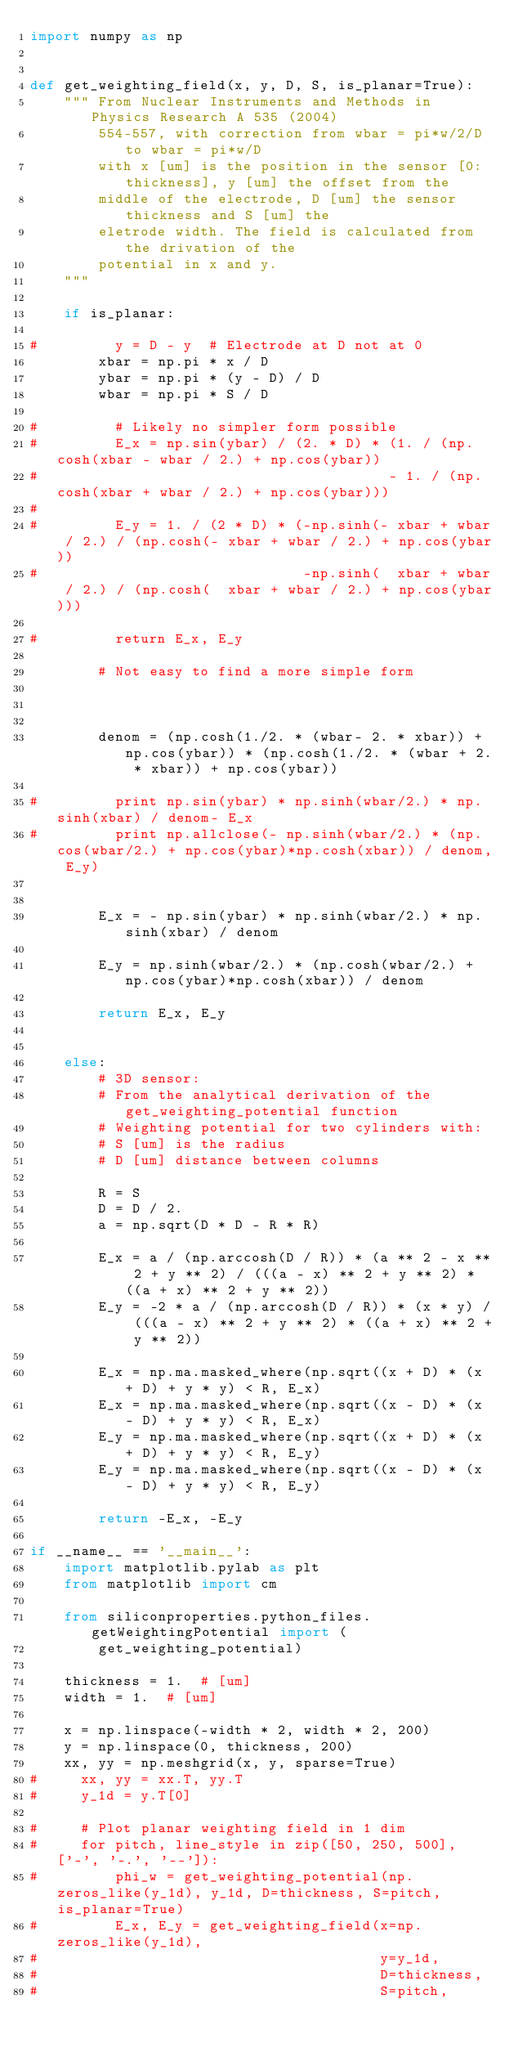<code> <loc_0><loc_0><loc_500><loc_500><_Python_>import numpy as np


def get_weighting_field(x, y, D, S, is_planar=True):
    """ From Nuclear Instruments and Methods in Physics Research A 535 (2004)
        554-557, with correction from wbar = pi*w/2/D to wbar = pi*w/D
        with x [um] is the position in the sensor [0:thickness], y [um] the offset from the
        middle of the electrode, D [um] the sensor thickness and S [um] the
        eletrode width. The field is calculated from the drivation of the
        potential in x and y.
    """

    if is_planar:

#         y = D - y  # Electrode at D not at 0
        xbar = np.pi * x / D
        ybar = np.pi * (y - D) / D
        wbar = np.pi * S / D

#         # Likely no simpler form possible
#         E_x = np.sin(ybar) / (2. * D) * (1. / (np.cosh(xbar - wbar / 2.) + np.cos(ybar)) 
#                                         - 1. / (np.cosh(xbar + wbar / 2.) + np.cos(ybar)))
#         
#         E_y = 1. / (2 * D) * (-np.sinh(- xbar + wbar / 2.) / (np.cosh(- xbar + wbar / 2.) + np.cos(ybar)) 
#                               -np.sinh(  xbar + wbar / 2.) / (np.cosh(  xbar + wbar / 2.) + np.cos(ybar)))
         
#         return E_x, E_y
        
        # Not easy to find a more simple form
        
        
        
        denom = (np.cosh(1./2. * (wbar- 2. * xbar)) + np.cos(ybar)) * (np.cosh(1./2. * (wbar + 2. * xbar)) + np.cos(ybar))
        
#         print np.sin(ybar) * np.sinh(wbar/2.) * np.sinh(xbar) / denom- E_x
#         print np.allclose(- np.sinh(wbar/2.) * (np.cos(wbar/2.) + np.cos(ybar)*np.cosh(xbar)) / denom, E_y)

        
        E_x = - np.sin(ybar) * np.sinh(wbar/2.) * np.sinh(xbar) / denom
        
        E_y = np.sinh(wbar/2.) * (np.cosh(wbar/2.) + np.cos(ybar)*np.cosh(xbar)) / denom
       
        return E_x, E_y
        

    else:
        # 3D sensor:
        # From the analytical derivation of the get_weighting_potential function
        # Weighting potential for two cylinders with:
        # S [um] is the radius
        # D [um] distance between columns

        R = S
        D = D / 2.
        a = np.sqrt(D * D - R * R)

        E_x = a / (np.arccosh(D / R)) * (a ** 2 - x ** 2 + y ** 2) / (((a - x) ** 2 + y ** 2) * ((a + x) ** 2 + y ** 2))
        E_y = -2 * a / (np.arccosh(D / R)) * (x * y) / (((a - x) ** 2 + y ** 2) * ((a + x) ** 2 + y ** 2))

        E_x = np.ma.masked_where(np.sqrt((x + D) * (x + D) + y * y) < R, E_x)
        E_x = np.ma.masked_where(np.sqrt((x - D) * (x - D) + y * y) < R, E_x)
        E_y = np.ma.masked_where(np.sqrt((x + D) * (x + D) + y * y) < R, E_y)
        E_y = np.ma.masked_where(np.sqrt((x - D) * (x - D) + y * y) < R, E_y)

        return -E_x, -E_y

if __name__ == '__main__':
    import matplotlib.pylab as plt
    from matplotlib import cm

    from siliconproperties.python_files.getWeightingPotential import (
        get_weighting_potential)

    thickness = 1.  # [um]
    width = 1.  # [um]

    x = np.linspace(-width * 2, width * 2, 200)
    y = np.linspace(0, thickness, 200)
    xx, yy = np.meshgrid(x, y, sparse=True)
#     xx, yy = xx.T, yy.T
#     y_1d = y.T[0]

#     # Plot planar weighting field in 1 dim
#     for pitch, line_style in zip([50, 250, 500], ['-', '-.', '--']):
#         phi_w = get_weighting_potential(np.zeros_like(y_1d), y_1d, D=thickness, S=pitch, is_planar=True)
#         E_x, E_y = get_weighting_field(x=np.zeros_like(y_1d),
#                                        y=y_1d,
#                                        D=thickness,
#                                        S=pitch,</code> 